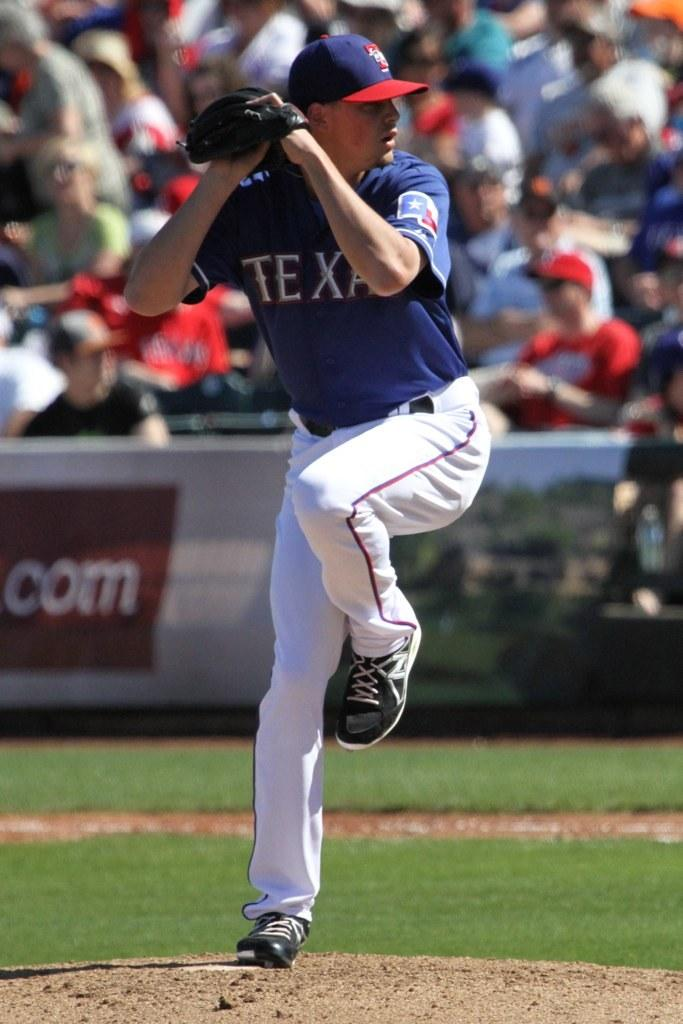<image>
Offer a succinct explanation of the picture presented. Texas Ranger pitcher that is preparing to throw a baseball. 